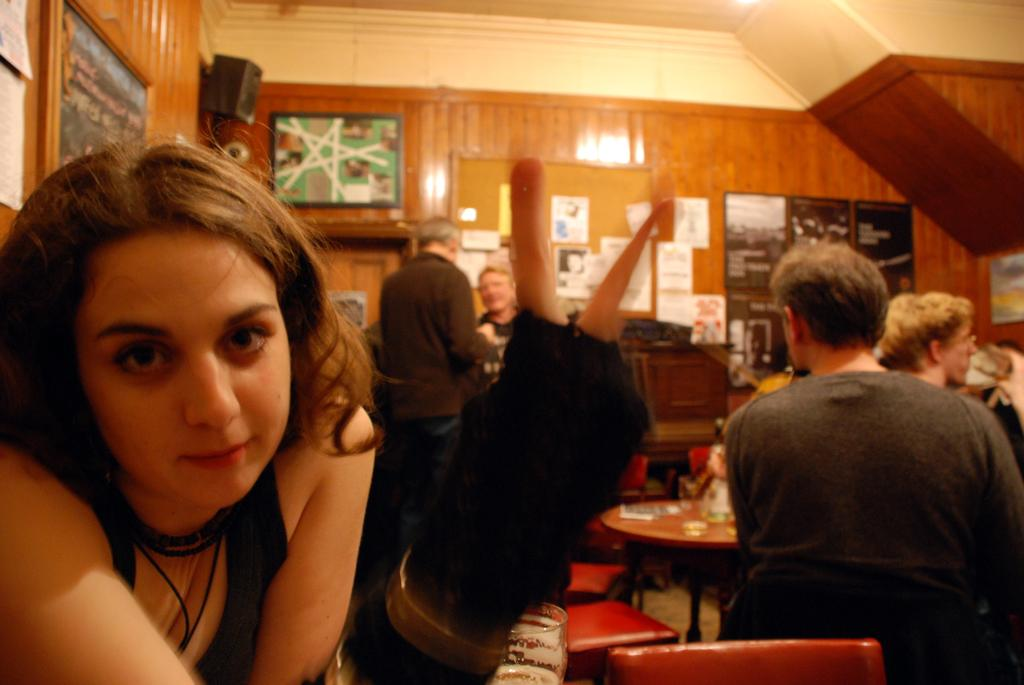How many people are in the image? There is a group of people in the image, but the exact number is not specified. What are the people doing in the image? The people are standing in the image. What is in front of the people? There is a table in front of the people. What is on the table? There is paper on the table. What can be seen in the background of the image? There is a wall with posters and speakers in the background. What type of copper material is being used to build the gun in the image? There is no copper material or gun present in the image. What is on the top of the wall in the image? The provided facts do not mention anything on top of the wall, so we cannot answer this question definitively. 